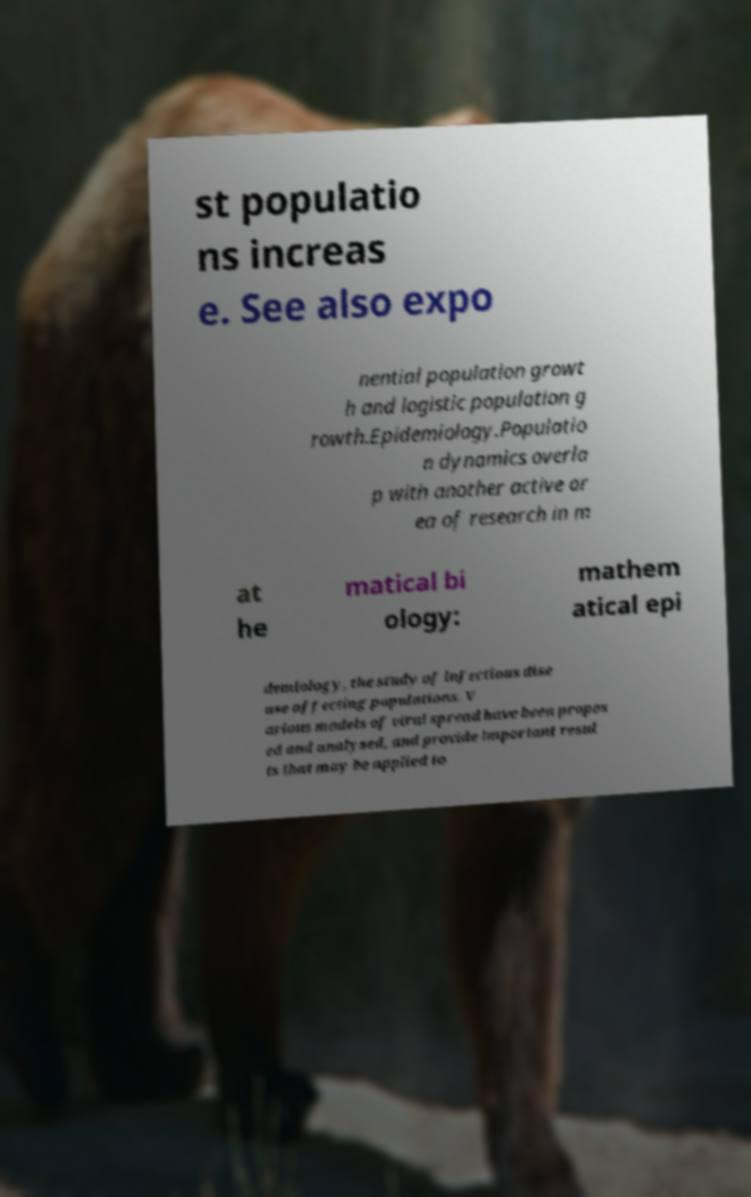For documentation purposes, I need the text within this image transcribed. Could you provide that? st populatio ns increas e. See also expo nential population growt h and logistic population g rowth.Epidemiology.Populatio n dynamics overla p with another active ar ea of research in m at he matical bi ology: mathem atical epi demiology, the study of infectious dise ase affecting populations. V arious models of viral spread have been propos ed and analysed, and provide important resul ts that may be applied to 